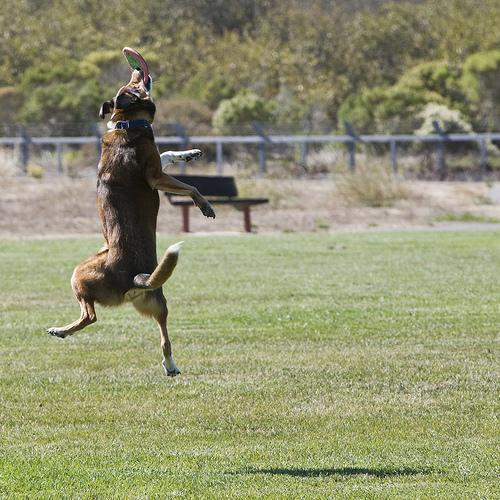Illustrate the image by identifying the main elements and subject's appearance. The image features a brown dog with white markings and a blue collar leaping to capture a red and green frisbee, surrounded by grass, trees, and a fence. Provide a short description of the principal subject and its engagement in the image. The image portrays an enthusiastic brown and white dog leaping into the air to catch a red and green frisbee with its mouth. Elucidate the primary focus of the image, along with the central action it conveys. The central focus of the image is an energetic brown and white dog leaping to catch red and green frisbee, set against a picturesque natural background. Describe the main focus of the picture, specifying the key elements in the scenery. The key focus is the energetic brown and white dog catching a colorful frisbee, set against a backdrop of green grass, trees, and a metal fence. Pen a concise depiction of the scene in the image, centering on the dominant subject. The image showcases a spirited brown and white canine soaring skyward to seize a flying red and green frisbee amidst a scenic green landscape. Construct a brief account of the main figure in the picture, focusing on its actions. The principal figure in the picture is a lively brown and white dog with a blue collar, who's jumping to grab a red and green frisbee from the air. Mention the primary animal present in the image and its actions with a brief description. A brown and white dog with a blue and silver collar is jumping and catching a red and green frisbee in its mouth. Provide a concise narrative of the scene in the image, focusing on the main subject. In a park with lush green grass, a lively brown and white dog leaps to snatch a red and green frisbee from the air. Summarize the picture, detailing the dog's action and its surroundings. The picture displays a brown and white dog in motion, catching a red and green frisbee while surrounded by vibrant green grass, trees, and a tall fence. Draft a brief explanation about the key subject in the image and its activity. The image's focal point is a playful brown and white dog that's in the midst of jumping to grab a red and green frisbee. 